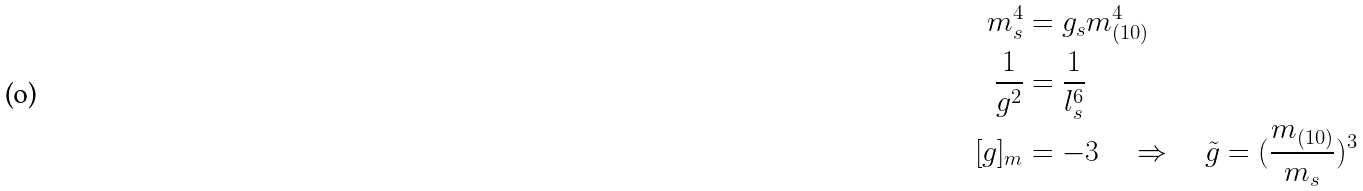Convert formula to latex. <formula><loc_0><loc_0><loc_500><loc_500>m _ { s } ^ { 4 } & = g _ { s } m _ { ( 1 0 ) } ^ { 4 } \\ \frac { 1 } { g ^ { 2 } } & = \frac { 1 } { l _ { s } ^ { 6 } } \\ [ g ] _ { m } & = - 3 \quad \Rightarrow \quad \tilde { g } = ( \frac { m _ { ( 1 0 ) } } { m _ { s } } ) ^ { 3 } \\</formula> 